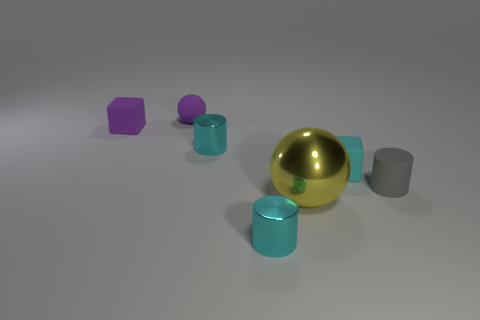Can you tell me more about the lighting in the image? The image features soft, diffused lighting with shadows that suggest a calm, indirect light source, enhancing the subtle reflections on the surfaces of the geometric objects. 